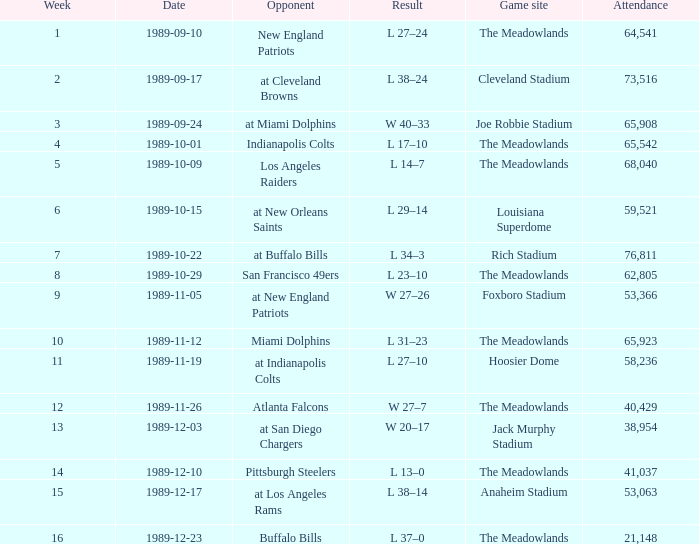Before week 2 started, on which day did they participate in the game? 1989-09-10. 